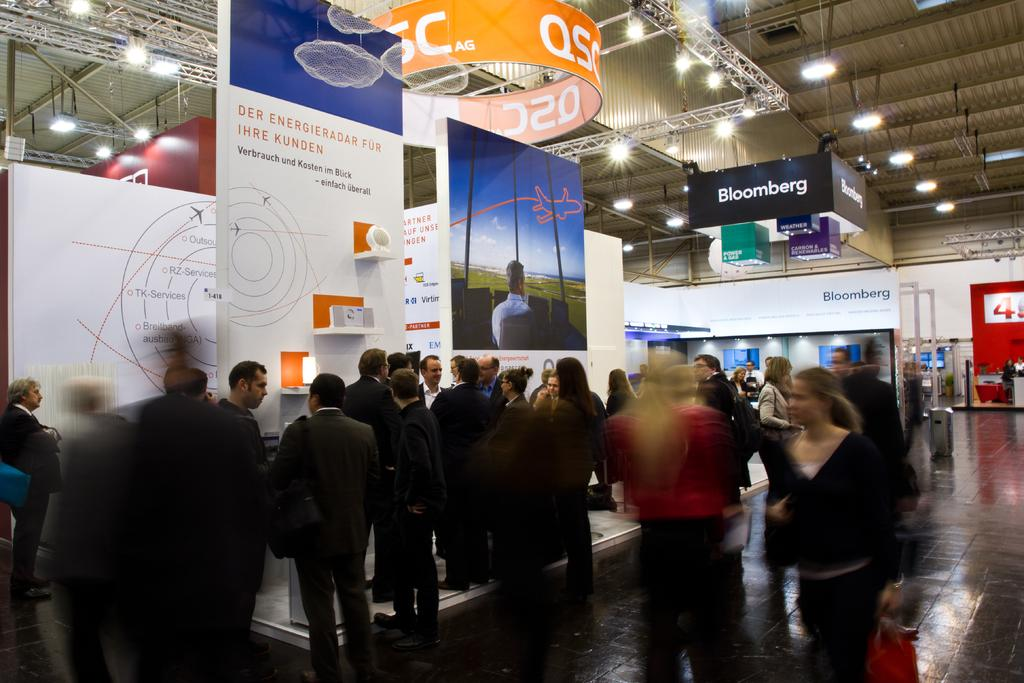What is happening with the people in the image? There are people standing in the image. Can you describe the woman's actions in the image? There is a woman walking in the image, and she is holding a bag in her hand. What can be seen in the background of the image? There are advertisement hoardings in the image. What type of lighting is present in the image? There are lights hanging in the image. What type of grass can be seen growing near the woman in the image? There is no grass visible in the image; it appears to be an urban setting with advertisement hoardings and lights. How many boys are present in the image? There is no mention of boys in the image; it only describes people and a woman walking. 